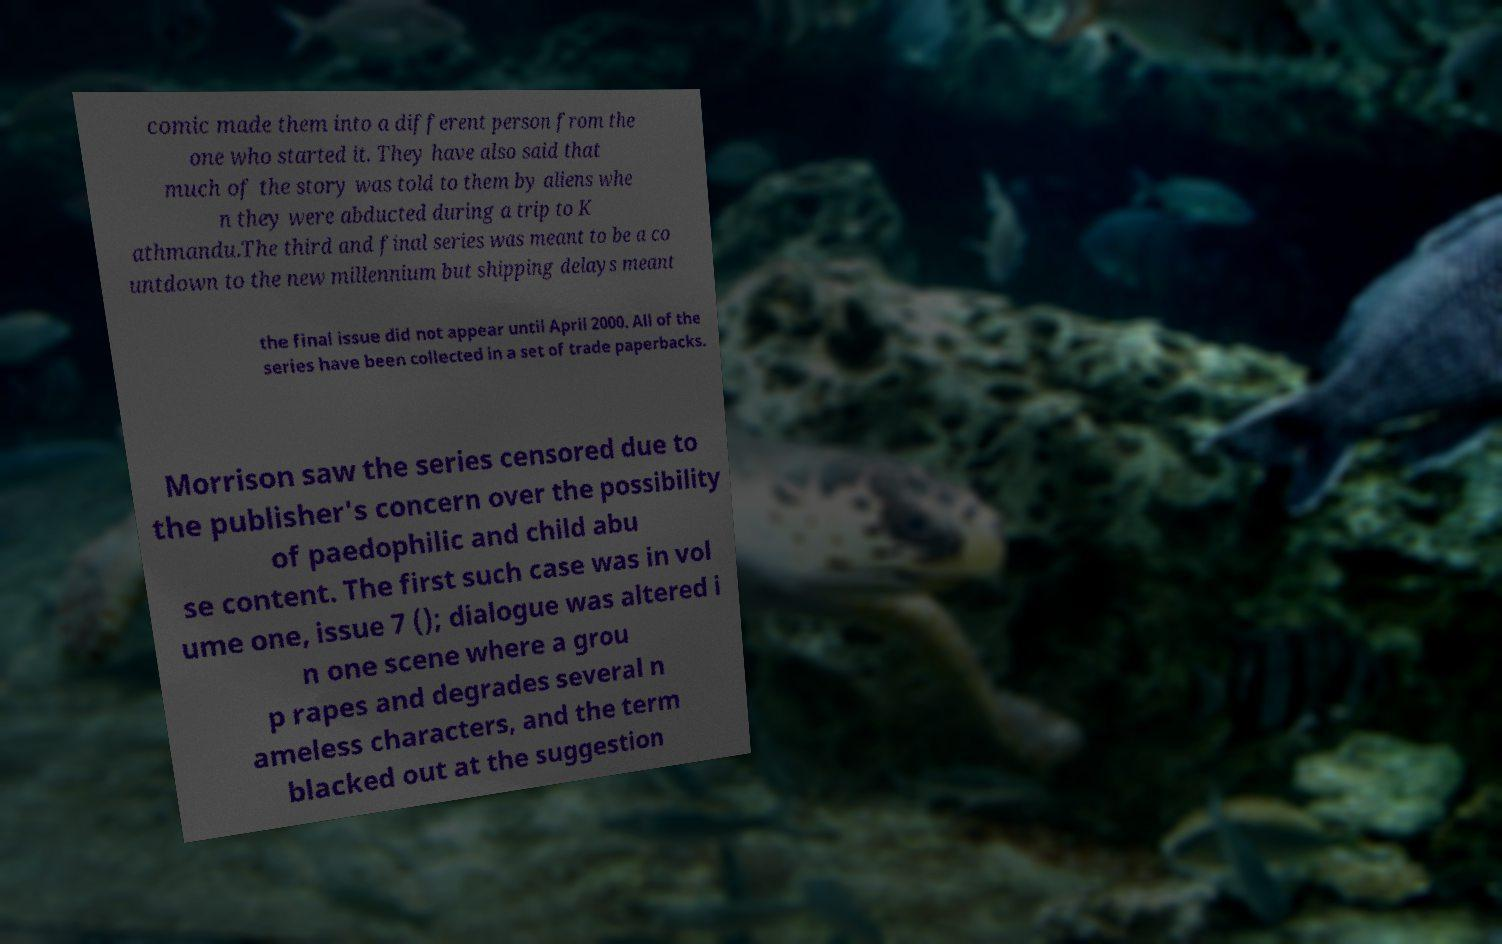I need the written content from this picture converted into text. Can you do that? comic made them into a different person from the one who started it. They have also said that much of the story was told to them by aliens whe n they were abducted during a trip to K athmandu.The third and final series was meant to be a co untdown to the new millennium but shipping delays meant the final issue did not appear until April 2000. All of the series have been collected in a set of trade paperbacks. Morrison saw the series censored due to the publisher's concern over the possibility of paedophilic and child abu se content. The first such case was in vol ume one, issue 7 (); dialogue was altered i n one scene where a grou p rapes and degrades several n ameless characters, and the term blacked out at the suggestion 